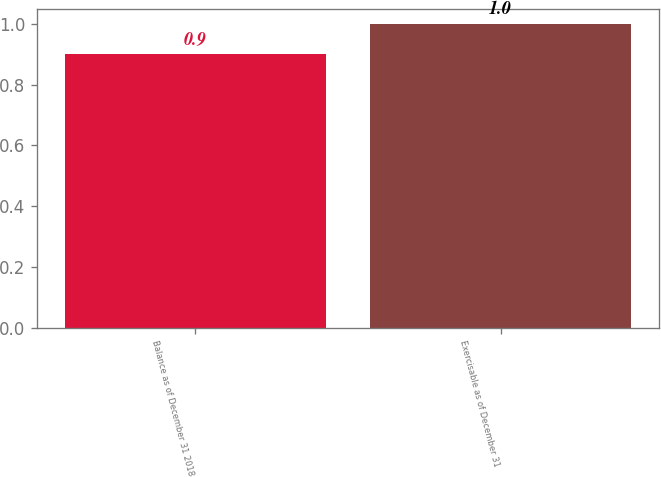Convert chart to OTSL. <chart><loc_0><loc_0><loc_500><loc_500><bar_chart><fcel>Balance as of December 31 2018<fcel>Exercisable as of December 31<nl><fcel>0.9<fcel>1<nl></chart> 